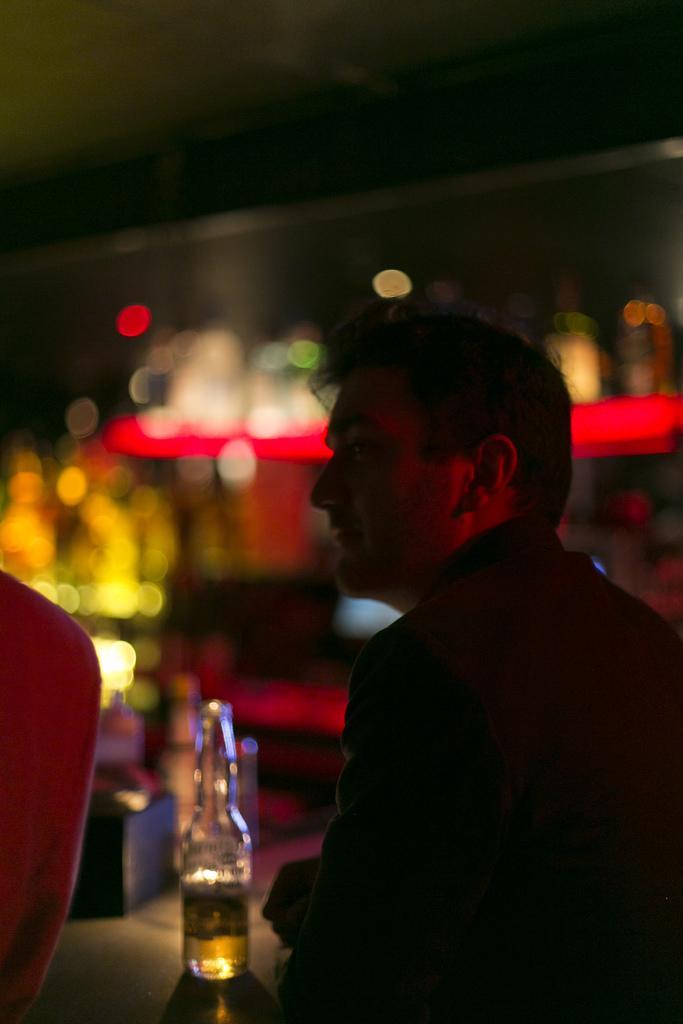Describe this image in one or two sentences. The background of the picture is completely blur. Here we can see a bottle in which there is a drink. At the right side of the picture we can see a man in black dress. 